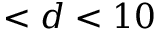Convert formula to latex. <formula><loc_0><loc_0><loc_500><loc_500>< d < 1 0</formula> 